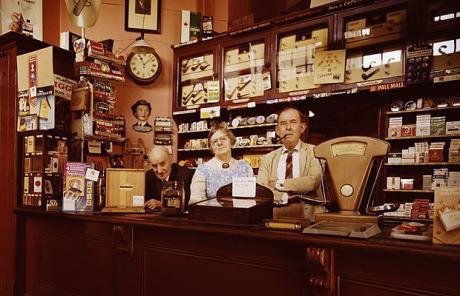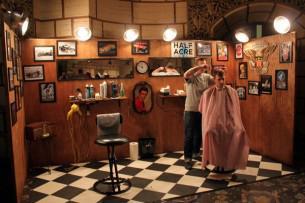The first image is the image on the left, the second image is the image on the right. Evaluate the accuracy of this statement regarding the images: "the left image contains at least three chairs, the right image only contains one.". Is it true? Answer yes or no. No. The first image is the image on the left, the second image is the image on the right. For the images displayed, is the sentence "in at least one image there is a single empty barber chair facing a mirror next to a framed picture." factually correct? Answer yes or no. No. 